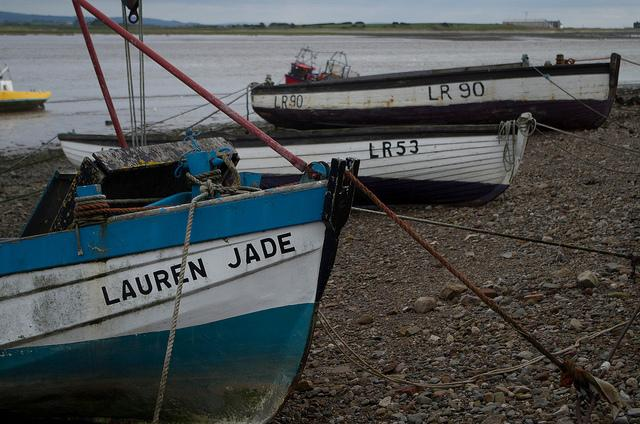What celebrity first name appears on the boat? lauren 